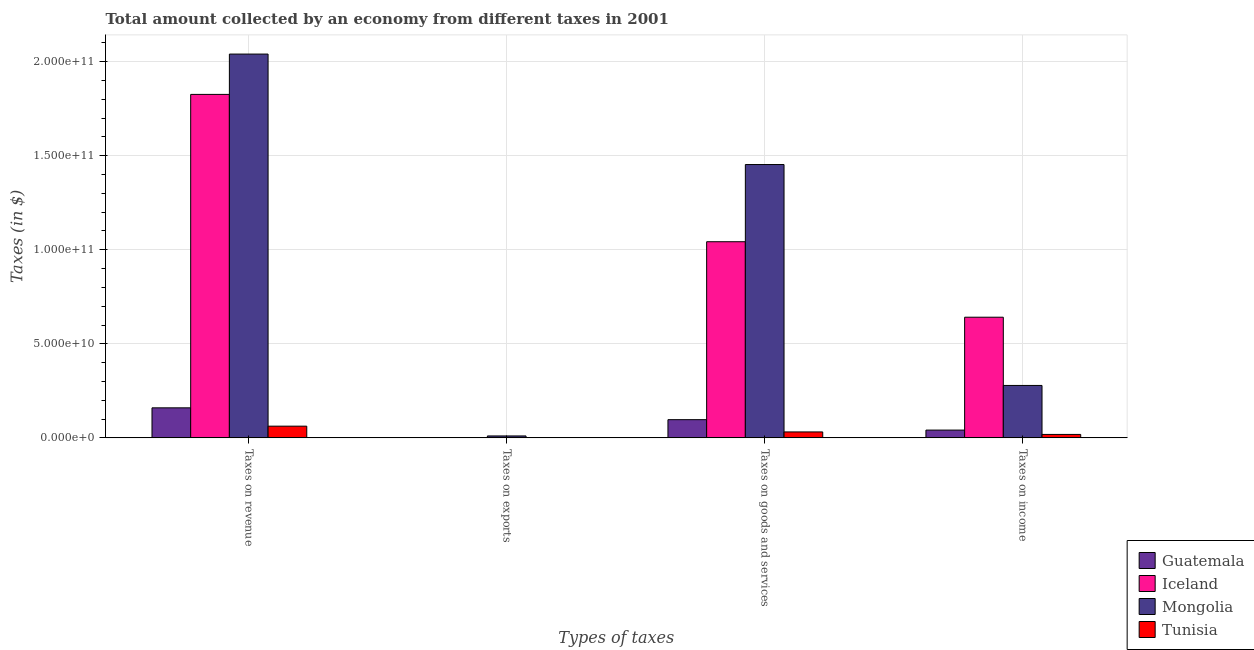How many bars are there on the 3rd tick from the left?
Your response must be concise. 4. How many bars are there on the 1st tick from the right?
Your answer should be compact. 4. What is the label of the 4th group of bars from the left?
Make the answer very short. Taxes on income. What is the amount collected as tax on goods in Iceland?
Make the answer very short. 1.04e+11. Across all countries, what is the maximum amount collected as tax on revenue?
Your answer should be very brief. 2.04e+11. Across all countries, what is the minimum amount collected as tax on income?
Give a very brief answer. 1.83e+09. In which country was the amount collected as tax on income maximum?
Ensure brevity in your answer.  Iceland. In which country was the amount collected as tax on goods minimum?
Ensure brevity in your answer.  Tunisia. What is the total amount collected as tax on goods in the graph?
Give a very brief answer. 2.62e+11. What is the difference between the amount collected as tax on income in Tunisia and that in Mongolia?
Ensure brevity in your answer.  -2.60e+1. What is the difference between the amount collected as tax on exports in Iceland and the amount collected as tax on income in Guatemala?
Make the answer very short. -4.14e+09. What is the average amount collected as tax on goods per country?
Your response must be concise. 6.56e+1. What is the difference between the amount collected as tax on revenue and amount collected as tax on goods in Guatemala?
Offer a terse response. 6.29e+09. In how many countries, is the amount collected as tax on goods greater than 90000000000 $?
Ensure brevity in your answer.  2. What is the ratio of the amount collected as tax on exports in Iceland to that in Mongolia?
Give a very brief answer. 0. Is the difference between the amount collected as tax on revenue in Tunisia and Guatemala greater than the difference between the amount collected as tax on exports in Tunisia and Guatemala?
Make the answer very short. No. What is the difference between the highest and the second highest amount collected as tax on exports?
Offer a terse response. 1.02e+09. What is the difference between the highest and the lowest amount collected as tax on goods?
Ensure brevity in your answer.  1.42e+11. In how many countries, is the amount collected as tax on exports greater than the average amount collected as tax on exports taken over all countries?
Offer a terse response. 1. What does the 1st bar from the left in Taxes on income represents?
Offer a terse response. Guatemala. What does the 2nd bar from the right in Taxes on income represents?
Offer a terse response. Mongolia. How many bars are there?
Provide a succinct answer. 16. Are all the bars in the graph horizontal?
Provide a short and direct response. No. How many countries are there in the graph?
Your answer should be compact. 4. Does the graph contain any zero values?
Offer a terse response. No. What is the title of the graph?
Give a very brief answer. Total amount collected by an economy from different taxes in 2001. Does "Oman" appear as one of the legend labels in the graph?
Offer a terse response. No. What is the label or title of the X-axis?
Ensure brevity in your answer.  Types of taxes. What is the label or title of the Y-axis?
Provide a short and direct response. Taxes (in $). What is the Taxes (in $) of Guatemala in Taxes on revenue?
Offer a terse response. 1.60e+1. What is the Taxes (in $) in Iceland in Taxes on revenue?
Offer a very short reply. 1.83e+11. What is the Taxes (in $) of Mongolia in Taxes on revenue?
Keep it short and to the point. 2.04e+11. What is the Taxes (in $) in Tunisia in Taxes on revenue?
Your answer should be compact. 6.22e+09. What is the Taxes (in $) in Guatemala in Taxes on exports?
Provide a succinct answer. 9.00e+05. What is the Taxes (in $) in Iceland in Taxes on exports?
Your response must be concise. 6.01e+05. What is the Taxes (in $) in Mongolia in Taxes on exports?
Ensure brevity in your answer.  1.03e+09. What is the Taxes (in $) in Tunisia in Taxes on exports?
Make the answer very short. 9.30e+06. What is the Taxes (in $) of Guatemala in Taxes on goods and services?
Give a very brief answer. 9.68e+09. What is the Taxes (in $) of Iceland in Taxes on goods and services?
Offer a very short reply. 1.04e+11. What is the Taxes (in $) of Mongolia in Taxes on goods and services?
Keep it short and to the point. 1.45e+11. What is the Taxes (in $) in Tunisia in Taxes on goods and services?
Provide a short and direct response. 3.16e+09. What is the Taxes (in $) in Guatemala in Taxes on income?
Offer a terse response. 4.14e+09. What is the Taxes (in $) of Iceland in Taxes on income?
Give a very brief answer. 6.42e+1. What is the Taxes (in $) in Mongolia in Taxes on income?
Your answer should be compact. 2.79e+1. What is the Taxes (in $) of Tunisia in Taxes on income?
Offer a very short reply. 1.83e+09. Across all Types of taxes, what is the maximum Taxes (in $) of Guatemala?
Your answer should be compact. 1.60e+1. Across all Types of taxes, what is the maximum Taxes (in $) of Iceland?
Provide a short and direct response. 1.83e+11. Across all Types of taxes, what is the maximum Taxes (in $) in Mongolia?
Offer a terse response. 2.04e+11. Across all Types of taxes, what is the maximum Taxes (in $) in Tunisia?
Your answer should be very brief. 6.22e+09. Across all Types of taxes, what is the minimum Taxes (in $) in Iceland?
Make the answer very short. 6.01e+05. Across all Types of taxes, what is the minimum Taxes (in $) of Mongolia?
Ensure brevity in your answer.  1.03e+09. Across all Types of taxes, what is the minimum Taxes (in $) of Tunisia?
Provide a short and direct response. 9.30e+06. What is the total Taxes (in $) in Guatemala in the graph?
Give a very brief answer. 2.98e+1. What is the total Taxes (in $) in Iceland in the graph?
Your answer should be very brief. 3.51e+11. What is the total Taxes (in $) of Mongolia in the graph?
Keep it short and to the point. 3.78e+11. What is the total Taxes (in $) in Tunisia in the graph?
Your response must be concise. 1.12e+1. What is the difference between the Taxes (in $) of Guatemala in Taxes on revenue and that in Taxes on exports?
Offer a terse response. 1.60e+1. What is the difference between the Taxes (in $) in Iceland in Taxes on revenue and that in Taxes on exports?
Your response must be concise. 1.83e+11. What is the difference between the Taxes (in $) of Mongolia in Taxes on revenue and that in Taxes on exports?
Give a very brief answer. 2.03e+11. What is the difference between the Taxes (in $) in Tunisia in Taxes on revenue and that in Taxes on exports?
Offer a very short reply. 6.21e+09. What is the difference between the Taxes (in $) of Guatemala in Taxes on revenue and that in Taxes on goods and services?
Provide a succinct answer. 6.29e+09. What is the difference between the Taxes (in $) in Iceland in Taxes on revenue and that in Taxes on goods and services?
Provide a succinct answer. 7.83e+1. What is the difference between the Taxes (in $) in Mongolia in Taxes on revenue and that in Taxes on goods and services?
Offer a terse response. 5.87e+1. What is the difference between the Taxes (in $) in Tunisia in Taxes on revenue and that in Taxes on goods and services?
Offer a terse response. 3.06e+09. What is the difference between the Taxes (in $) of Guatemala in Taxes on revenue and that in Taxes on income?
Your answer should be very brief. 1.18e+1. What is the difference between the Taxes (in $) of Iceland in Taxes on revenue and that in Taxes on income?
Give a very brief answer. 1.18e+11. What is the difference between the Taxes (in $) in Mongolia in Taxes on revenue and that in Taxes on income?
Offer a terse response. 1.76e+11. What is the difference between the Taxes (in $) of Tunisia in Taxes on revenue and that in Taxes on income?
Your answer should be very brief. 4.39e+09. What is the difference between the Taxes (in $) in Guatemala in Taxes on exports and that in Taxes on goods and services?
Your answer should be very brief. -9.68e+09. What is the difference between the Taxes (in $) of Iceland in Taxes on exports and that in Taxes on goods and services?
Your response must be concise. -1.04e+11. What is the difference between the Taxes (in $) of Mongolia in Taxes on exports and that in Taxes on goods and services?
Offer a terse response. -1.44e+11. What is the difference between the Taxes (in $) of Tunisia in Taxes on exports and that in Taxes on goods and services?
Ensure brevity in your answer.  -3.15e+09. What is the difference between the Taxes (in $) in Guatemala in Taxes on exports and that in Taxes on income?
Your response must be concise. -4.14e+09. What is the difference between the Taxes (in $) of Iceland in Taxes on exports and that in Taxes on income?
Your answer should be very brief. -6.42e+1. What is the difference between the Taxes (in $) of Mongolia in Taxes on exports and that in Taxes on income?
Your response must be concise. -2.68e+1. What is the difference between the Taxes (in $) in Tunisia in Taxes on exports and that in Taxes on income?
Your answer should be compact. -1.82e+09. What is the difference between the Taxes (in $) of Guatemala in Taxes on goods and services and that in Taxes on income?
Ensure brevity in your answer.  5.54e+09. What is the difference between the Taxes (in $) of Iceland in Taxes on goods and services and that in Taxes on income?
Ensure brevity in your answer.  4.01e+1. What is the difference between the Taxes (in $) of Mongolia in Taxes on goods and services and that in Taxes on income?
Make the answer very short. 1.17e+11. What is the difference between the Taxes (in $) in Tunisia in Taxes on goods and services and that in Taxes on income?
Offer a terse response. 1.33e+09. What is the difference between the Taxes (in $) of Guatemala in Taxes on revenue and the Taxes (in $) of Iceland in Taxes on exports?
Offer a very short reply. 1.60e+1. What is the difference between the Taxes (in $) in Guatemala in Taxes on revenue and the Taxes (in $) in Mongolia in Taxes on exports?
Keep it short and to the point. 1.49e+1. What is the difference between the Taxes (in $) in Guatemala in Taxes on revenue and the Taxes (in $) in Tunisia in Taxes on exports?
Ensure brevity in your answer.  1.60e+1. What is the difference between the Taxes (in $) in Iceland in Taxes on revenue and the Taxes (in $) in Mongolia in Taxes on exports?
Your answer should be very brief. 1.82e+11. What is the difference between the Taxes (in $) in Iceland in Taxes on revenue and the Taxes (in $) in Tunisia in Taxes on exports?
Give a very brief answer. 1.83e+11. What is the difference between the Taxes (in $) in Mongolia in Taxes on revenue and the Taxes (in $) in Tunisia in Taxes on exports?
Keep it short and to the point. 2.04e+11. What is the difference between the Taxes (in $) of Guatemala in Taxes on revenue and the Taxes (in $) of Iceland in Taxes on goods and services?
Your answer should be very brief. -8.83e+1. What is the difference between the Taxes (in $) of Guatemala in Taxes on revenue and the Taxes (in $) of Mongolia in Taxes on goods and services?
Offer a terse response. -1.29e+11. What is the difference between the Taxes (in $) in Guatemala in Taxes on revenue and the Taxes (in $) in Tunisia in Taxes on goods and services?
Give a very brief answer. 1.28e+1. What is the difference between the Taxes (in $) of Iceland in Taxes on revenue and the Taxes (in $) of Mongolia in Taxes on goods and services?
Your answer should be compact. 3.73e+1. What is the difference between the Taxes (in $) of Iceland in Taxes on revenue and the Taxes (in $) of Tunisia in Taxes on goods and services?
Make the answer very short. 1.79e+11. What is the difference between the Taxes (in $) in Mongolia in Taxes on revenue and the Taxes (in $) in Tunisia in Taxes on goods and services?
Offer a terse response. 2.01e+11. What is the difference between the Taxes (in $) of Guatemala in Taxes on revenue and the Taxes (in $) of Iceland in Taxes on income?
Your answer should be compact. -4.82e+1. What is the difference between the Taxes (in $) of Guatemala in Taxes on revenue and the Taxes (in $) of Mongolia in Taxes on income?
Make the answer very short. -1.19e+1. What is the difference between the Taxes (in $) in Guatemala in Taxes on revenue and the Taxes (in $) in Tunisia in Taxes on income?
Your answer should be very brief. 1.41e+1. What is the difference between the Taxes (in $) in Iceland in Taxes on revenue and the Taxes (in $) in Mongolia in Taxes on income?
Provide a short and direct response. 1.55e+11. What is the difference between the Taxes (in $) of Iceland in Taxes on revenue and the Taxes (in $) of Tunisia in Taxes on income?
Ensure brevity in your answer.  1.81e+11. What is the difference between the Taxes (in $) in Mongolia in Taxes on revenue and the Taxes (in $) in Tunisia in Taxes on income?
Make the answer very short. 2.02e+11. What is the difference between the Taxes (in $) of Guatemala in Taxes on exports and the Taxes (in $) of Iceland in Taxes on goods and services?
Give a very brief answer. -1.04e+11. What is the difference between the Taxes (in $) of Guatemala in Taxes on exports and the Taxes (in $) of Mongolia in Taxes on goods and services?
Offer a terse response. -1.45e+11. What is the difference between the Taxes (in $) of Guatemala in Taxes on exports and the Taxes (in $) of Tunisia in Taxes on goods and services?
Your answer should be compact. -3.16e+09. What is the difference between the Taxes (in $) in Iceland in Taxes on exports and the Taxes (in $) in Mongolia in Taxes on goods and services?
Your answer should be compact. -1.45e+11. What is the difference between the Taxes (in $) in Iceland in Taxes on exports and the Taxes (in $) in Tunisia in Taxes on goods and services?
Offer a terse response. -3.16e+09. What is the difference between the Taxes (in $) in Mongolia in Taxes on exports and the Taxes (in $) in Tunisia in Taxes on goods and services?
Offer a very short reply. -2.13e+09. What is the difference between the Taxes (in $) of Guatemala in Taxes on exports and the Taxes (in $) of Iceland in Taxes on income?
Your answer should be compact. -6.42e+1. What is the difference between the Taxes (in $) of Guatemala in Taxes on exports and the Taxes (in $) of Mongolia in Taxes on income?
Your response must be concise. -2.79e+1. What is the difference between the Taxes (in $) of Guatemala in Taxes on exports and the Taxes (in $) of Tunisia in Taxes on income?
Give a very brief answer. -1.83e+09. What is the difference between the Taxes (in $) of Iceland in Taxes on exports and the Taxes (in $) of Mongolia in Taxes on income?
Your answer should be very brief. -2.79e+1. What is the difference between the Taxes (in $) in Iceland in Taxes on exports and the Taxes (in $) in Tunisia in Taxes on income?
Your answer should be very brief. -1.83e+09. What is the difference between the Taxes (in $) of Mongolia in Taxes on exports and the Taxes (in $) of Tunisia in Taxes on income?
Offer a terse response. -8.01e+08. What is the difference between the Taxes (in $) in Guatemala in Taxes on goods and services and the Taxes (in $) in Iceland in Taxes on income?
Offer a very short reply. -5.45e+1. What is the difference between the Taxes (in $) in Guatemala in Taxes on goods and services and the Taxes (in $) in Mongolia in Taxes on income?
Offer a very short reply. -1.82e+1. What is the difference between the Taxes (in $) of Guatemala in Taxes on goods and services and the Taxes (in $) of Tunisia in Taxes on income?
Your answer should be very brief. 7.85e+09. What is the difference between the Taxes (in $) in Iceland in Taxes on goods and services and the Taxes (in $) in Mongolia in Taxes on income?
Provide a short and direct response. 7.64e+1. What is the difference between the Taxes (in $) of Iceland in Taxes on goods and services and the Taxes (in $) of Tunisia in Taxes on income?
Offer a very short reply. 1.02e+11. What is the difference between the Taxes (in $) in Mongolia in Taxes on goods and services and the Taxes (in $) in Tunisia in Taxes on income?
Your response must be concise. 1.44e+11. What is the average Taxes (in $) in Guatemala per Types of taxes?
Offer a terse response. 7.45e+09. What is the average Taxes (in $) of Iceland per Types of taxes?
Give a very brief answer. 8.78e+1. What is the average Taxes (in $) of Mongolia per Types of taxes?
Your answer should be compact. 9.46e+1. What is the average Taxes (in $) of Tunisia per Types of taxes?
Provide a succinct answer. 2.80e+09. What is the difference between the Taxes (in $) in Guatemala and Taxes (in $) in Iceland in Taxes on revenue?
Give a very brief answer. -1.67e+11. What is the difference between the Taxes (in $) in Guatemala and Taxes (in $) in Mongolia in Taxes on revenue?
Give a very brief answer. -1.88e+11. What is the difference between the Taxes (in $) of Guatemala and Taxes (in $) of Tunisia in Taxes on revenue?
Keep it short and to the point. 9.74e+09. What is the difference between the Taxes (in $) in Iceland and Taxes (in $) in Mongolia in Taxes on revenue?
Ensure brevity in your answer.  -2.14e+1. What is the difference between the Taxes (in $) in Iceland and Taxes (in $) in Tunisia in Taxes on revenue?
Give a very brief answer. 1.76e+11. What is the difference between the Taxes (in $) of Mongolia and Taxes (in $) of Tunisia in Taxes on revenue?
Keep it short and to the point. 1.98e+11. What is the difference between the Taxes (in $) of Guatemala and Taxes (in $) of Iceland in Taxes on exports?
Your response must be concise. 2.99e+05. What is the difference between the Taxes (in $) of Guatemala and Taxes (in $) of Mongolia in Taxes on exports?
Offer a very short reply. -1.03e+09. What is the difference between the Taxes (in $) in Guatemala and Taxes (in $) in Tunisia in Taxes on exports?
Your response must be concise. -8.40e+06. What is the difference between the Taxes (in $) in Iceland and Taxes (in $) in Mongolia in Taxes on exports?
Your answer should be compact. -1.03e+09. What is the difference between the Taxes (in $) in Iceland and Taxes (in $) in Tunisia in Taxes on exports?
Offer a terse response. -8.70e+06. What is the difference between the Taxes (in $) of Mongolia and Taxes (in $) of Tunisia in Taxes on exports?
Your answer should be very brief. 1.02e+09. What is the difference between the Taxes (in $) in Guatemala and Taxes (in $) in Iceland in Taxes on goods and services?
Keep it short and to the point. -9.46e+1. What is the difference between the Taxes (in $) in Guatemala and Taxes (in $) in Mongolia in Taxes on goods and services?
Make the answer very short. -1.36e+11. What is the difference between the Taxes (in $) of Guatemala and Taxes (in $) of Tunisia in Taxes on goods and services?
Give a very brief answer. 6.52e+09. What is the difference between the Taxes (in $) in Iceland and Taxes (in $) in Mongolia in Taxes on goods and services?
Offer a very short reply. -4.10e+1. What is the difference between the Taxes (in $) in Iceland and Taxes (in $) in Tunisia in Taxes on goods and services?
Provide a succinct answer. 1.01e+11. What is the difference between the Taxes (in $) in Mongolia and Taxes (in $) in Tunisia in Taxes on goods and services?
Your response must be concise. 1.42e+11. What is the difference between the Taxes (in $) in Guatemala and Taxes (in $) in Iceland in Taxes on income?
Keep it short and to the point. -6.00e+1. What is the difference between the Taxes (in $) in Guatemala and Taxes (in $) in Mongolia in Taxes on income?
Offer a terse response. -2.37e+1. What is the difference between the Taxes (in $) of Guatemala and Taxes (in $) of Tunisia in Taxes on income?
Give a very brief answer. 2.31e+09. What is the difference between the Taxes (in $) of Iceland and Taxes (in $) of Mongolia in Taxes on income?
Your response must be concise. 3.63e+1. What is the difference between the Taxes (in $) in Iceland and Taxes (in $) in Tunisia in Taxes on income?
Ensure brevity in your answer.  6.23e+1. What is the difference between the Taxes (in $) of Mongolia and Taxes (in $) of Tunisia in Taxes on income?
Give a very brief answer. 2.60e+1. What is the ratio of the Taxes (in $) in Guatemala in Taxes on revenue to that in Taxes on exports?
Your answer should be compact. 1.77e+04. What is the ratio of the Taxes (in $) in Iceland in Taxes on revenue to that in Taxes on exports?
Give a very brief answer. 3.04e+05. What is the ratio of the Taxes (in $) of Mongolia in Taxes on revenue to that in Taxes on exports?
Ensure brevity in your answer.  198.71. What is the ratio of the Taxes (in $) in Tunisia in Taxes on revenue to that in Taxes on exports?
Your response must be concise. 668.98. What is the ratio of the Taxes (in $) in Guatemala in Taxes on revenue to that in Taxes on goods and services?
Give a very brief answer. 1.65. What is the ratio of the Taxes (in $) of Iceland in Taxes on revenue to that in Taxes on goods and services?
Offer a very short reply. 1.75. What is the ratio of the Taxes (in $) of Mongolia in Taxes on revenue to that in Taxes on goods and services?
Give a very brief answer. 1.4. What is the ratio of the Taxes (in $) in Tunisia in Taxes on revenue to that in Taxes on goods and services?
Give a very brief answer. 1.97. What is the ratio of the Taxes (in $) in Guatemala in Taxes on revenue to that in Taxes on income?
Offer a very short reply. 3.86. What is the ratio of the Taxes (in $) in Iceland in Taxes on revenue to that in Taxes on income?
Your response must be concise. 2.85. What is the ratio of the Taxes (in $) of Mongolia in Taxes on revenue to that in Taxes on income?
Offer a terse response. 7.32. What is the ratio of the Taxes (in $) of Tunisia in Taxes on revenue to that in Taxes on income?
Make the answer very short. 3.4. What is the ratio of the Taxes (in $) of Guatemala in Taxes on exports to that in Taxes on goods and services?
Give a very brief answer. 0. What is the ratio of the Taxes (in $) in Mongolia in Taxes on exports to that in Taxes on goods and services?
Provide a succinct answer. 0.01. What is the ratio of the Taxes (in $) in Tunisia in Taxes on exports to that in Taxes on goods and services?
Give a very brief answer. 0. What is the ratio of the Taxes (in $) of Mongolia in Taxes on exports to that in Taxes on income?
Make the answer very short. 0.04. What is the ratio of the Taxes (in $) in Tunisia in Taxes on exports to that in Taxes on income?
Make the answer very short. 0.01. What is the ratio of the Taxes (in $) in Guatemala in Taxes on goods and services to that in Taxes on income?
Provide a short and direct response. 2.34. What is the ratio of the Taxes (in $) of Iceland in Taxes on goods and services to that in Taxes on income?
Ensure brevity in your answer.  1.63. What is the ratio of the Taxes (in $) of Mongolia in Taxes on goods and services to that in Taxes on income?
Provide a succinct answer. 5.21. What is the ratio of the Taxes (in $) in Tunisia in Taxes on goods and services to that in Taxes on income?
Your answer should be compact. 1.73. What is the difference between the highest and the second highest Taxes (in $) of Guatemala?
Give a very brief answer. 6.29e+09. What is the difference between the highest and the second highest Taxes (in $) in Iceland?
Provide a short and direct response. 7.83e+1. What is the difference between the highest and the second highest Taxes (in $) in Mongolia?
Provide a succinct answer. 5.87e+1. What is the difference between the highest and the second highest Taxes (in $) of Tunisia?
Your response must be concise. 3.06e+09. What is the difference between the highest and the lowest Taxes (in $) of Guatemala?
Your answer should be compact. 1.60e+1. What is the difference between the highest and the lowest Taxes (in $) of Iceland?
Keep it short and to the point. 1.83e+11. What is the difference between the highest and the lowest Taxes (in $) in Mongolia?
Give a very brief answer. 2.03e+11. What is the difference between the highest and the lowest Taxes (in $) in Tunisia?
Ensure brevity in your answer.  6.21e+09. 